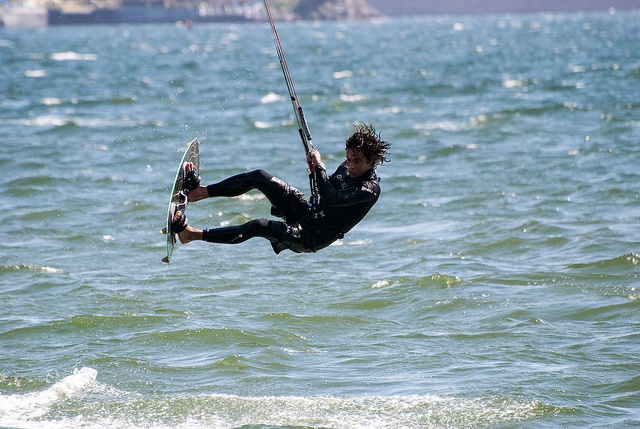Describe the objects in this image and their specific colors. I can see people in darkgray, black, gray, and maroon tones and surfboard in darkgray, gray, black, and ivory tones in this image. 